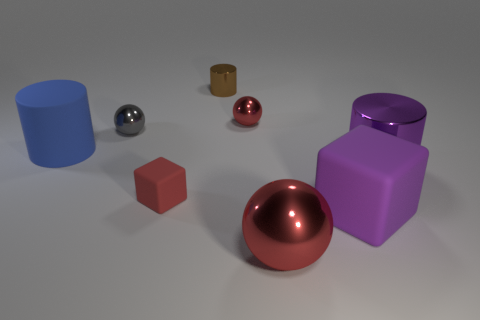What is the size of the rubber object that is the same color as the big metal sphere?
Ensure brevity in your answer.  Small. Are there fewer blue matte cylinders that are on the right side of the tiny brown shiny cylinder than things?
Keep it short and to the point. Yes. There is a thing that is both behind the tiny red rubber cube and in front of the large blue rubber thing; what is its color?
Keep it short and to the point. Purple. What number of other things are the same shape as the gray object?
Your answer should be compact. 2. Is the number of metallic things that are on the left side of the large sphere less than the number of objects that are right of the brown object?
Provide a short and direct response. Yes. Are the big blue cylinder and the red object that is on the right side of the small red metal thing made of the same material?
Your response must be concise. No. Are there more large rubber cubes than big brown rubber blocks?
Make the answer very short. Yes. There is a big rubber thing left of the tiny red thing in front of the blue cylinder that is on the left side of the small gray object; what is its shape?
Your answer should be very brief. Cylinder. Are the large cylinder left of the brown cylinder and the tiny object in front of the big blue rubber object made of the same material?
Provide a short and direct response. Yes. There is a small red thing that is the same material as the tiny brown thing; what is its shape?
Offer a very short reply. Sphere. 